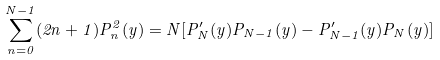<formula> <loc_0><loc_0><loc_500><loc_500>\sum _ { n = 0 } ^ { N - 1 } ( 2 n + 1 ) P _ { n } ^ { 2 } ( y ) = N [ P _ { N } ^ { \prime } ( y ) P _ { N - 1 } ( y ) - P _ { N - 1 } ^ { \prime } ( y ) P _ { N } ( y ) ]</formula> 